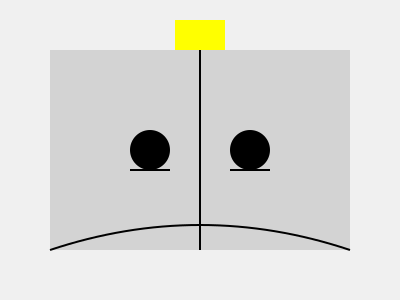In Plato's Allegory of the Cave, what do the stick figures on the left side of the wall represent, and how does this relate to Rosati's work on self-creation and authenticity? 1. The image represents Plato's Allegory of the Cave:
   - The large rectangle represents the cave.
   - The vertical line in the middle represents a wall.
   - The stick figures on the left side are prisoners.
   - The yellow rectangle at the top represents a fire or light source.

2. The prisoners on the left side of the wall represent:
   - Individuals who only perceive shadows (their limited reality).
   - They are chained and unable to turn their heads, limiting their perspective.

3. This representation relates to Rosati's work on self-creation and authenticity:
   - Rosati argues that individuals engage in self-creation through reflection and choice.
   - The prisoners, like individuals in Rosati's view, are constrained by their current understanding and experiences.

4. Connection to Rosati's ideas:
   - The prisoners' limited perception parallels Rosati's concept of how our current values and beliefs shape our choices.
   - Rosati suggests that authenticity involves critically examining and potentially revising our values.
   - In the allegory, freeing a prisoner to see beyond the shadows is analogous to Rosati's idea of expanding one's perspective for authentic self-creation.

5. Implications for philosophical inquiry:
   - Both Plato and Rosati emphasize the importance of questioning one's beliefs and seeking broader understanding.
   - The allegory and Rosati's work highlight the potential for personal growth and enlightenment through critical reflection.
Answer: Prisoners with limited perception, reflecting Rosati's ideas on constrained self-creation and the potential for expanded authenticity through critical reflection. 